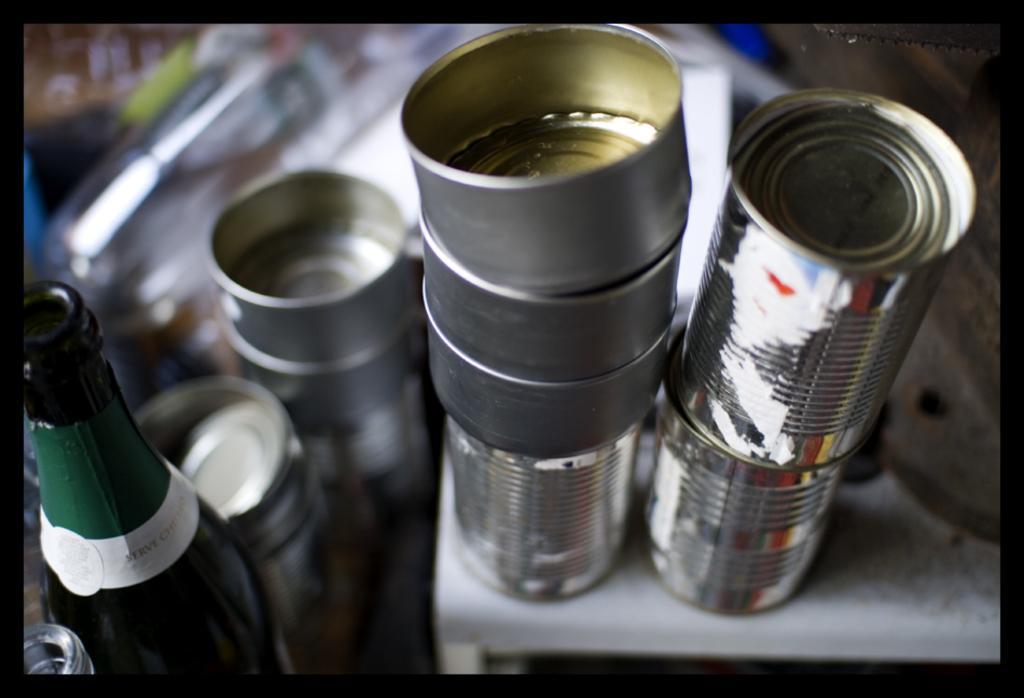In one or two sentences, can you explain what this image depicts? In this image we can a bottle on the left side of the image and there are objects which looks like tens and some other things and the background image is blurred. 